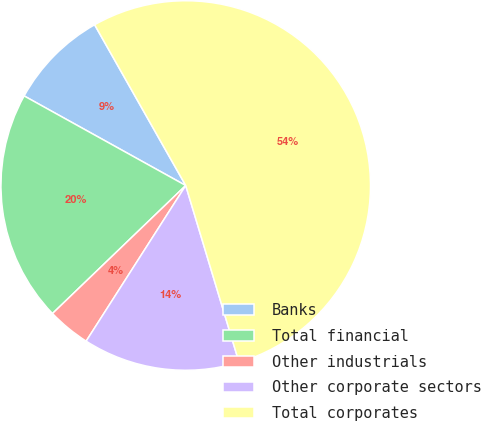Convert chart to OTSL. <chart><loc_0><loc_0><loc_500><loc_500><pie_chart><fcel>Banks<fcel>Total financial<fcel>Other industrials<fcel>Other corporate sectors<fcel>Total corporates<nl><fcel>8.74%<fcel>20.24%<fcel>3.76%<fcel>13.72%<fcel>53.55%<nl></chart> 